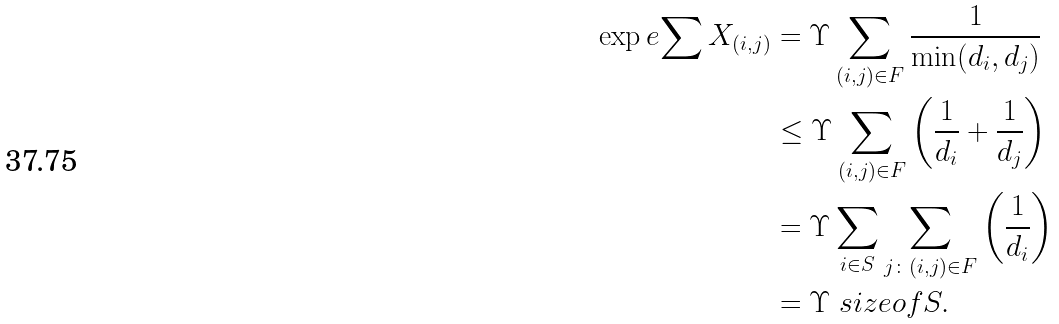Convert formula to latex. <formula><loc_0><loc_0><loc_500><loc_500>\exp e { \sum X _ { ( i , j ) } } & = \Upsilon \sum _ { ( i , j ) \in F } \frac { 1 } { \min ( d _ { i } , d _ { j } ) } \\ & \leq \Upsilon \sum _ { ( i , j ) \in F } \left ( \frac { 1 } { d _ { i } } + \frac { 1 } { d _ { j } } \right ) \\ & = \Upsilon \sum _ { i \in S } \sum _ { j \colon ( i , j ) \in F } \left ( \frac { 1 } { d _ { i } } \right ) \\ & = \Upsilon \ s i z e o f { S } .</formula> 